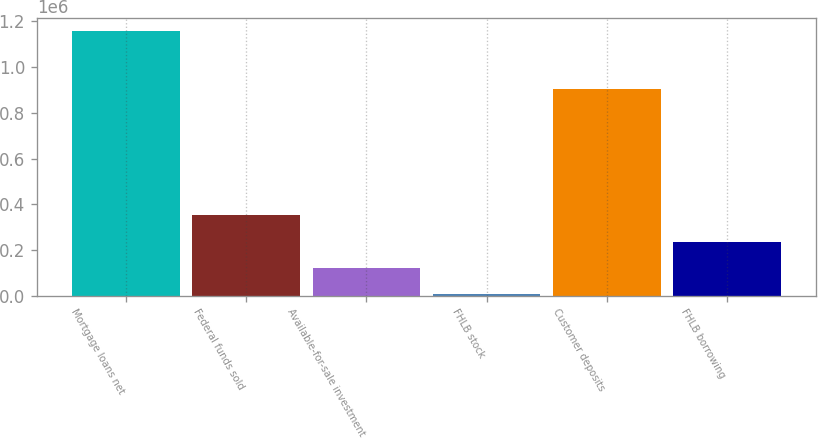<chart> <loc_0><loc_0><loc_500><loc_500><bar_chart><fcel>Mortgage loans net<fcel>Federal funds sold<fcel>Available-for-sale investment<fcel>FHLB stock<fcel>Customer deposits<fcel>FHLB borrowing<nl><fcel>1.15736e+06<fcel>352021<fcel>121924<fcel>6876<fcel>904836<fcel>236973<nl></chart> 